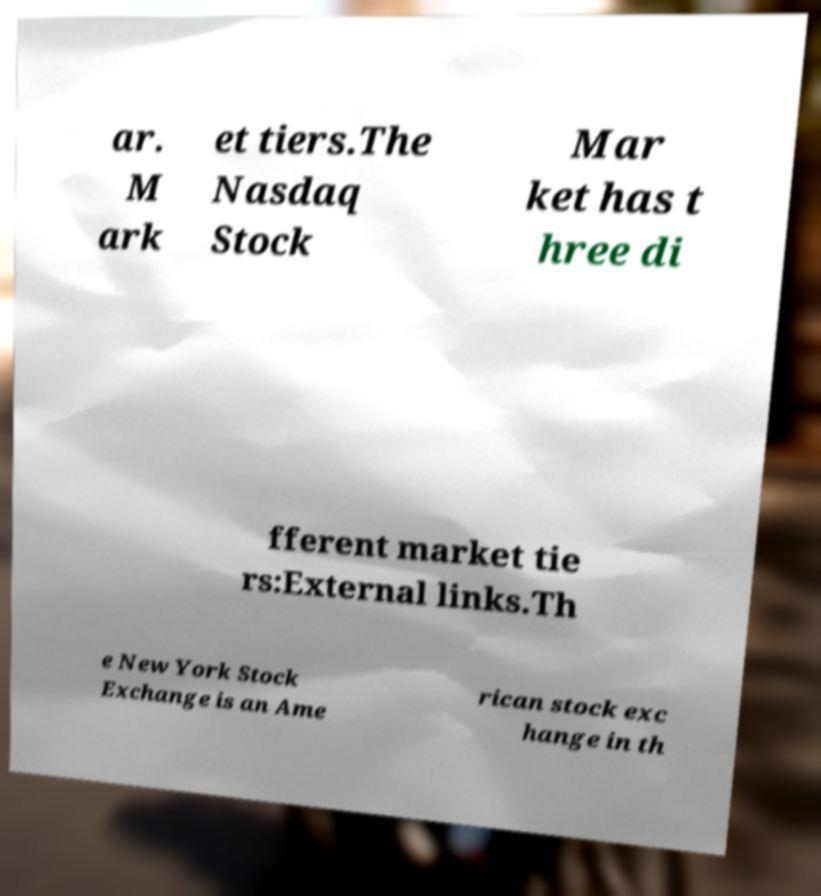For documentation purposes, I need the text within this image transcribed. Could you provide that? ar. M ark et tiers.The Nasdaq Stock Mar ket has t hree di fferent market tie rs:External links.Th e New York Stock Exchange is an Ame rican stock exc hange in th 